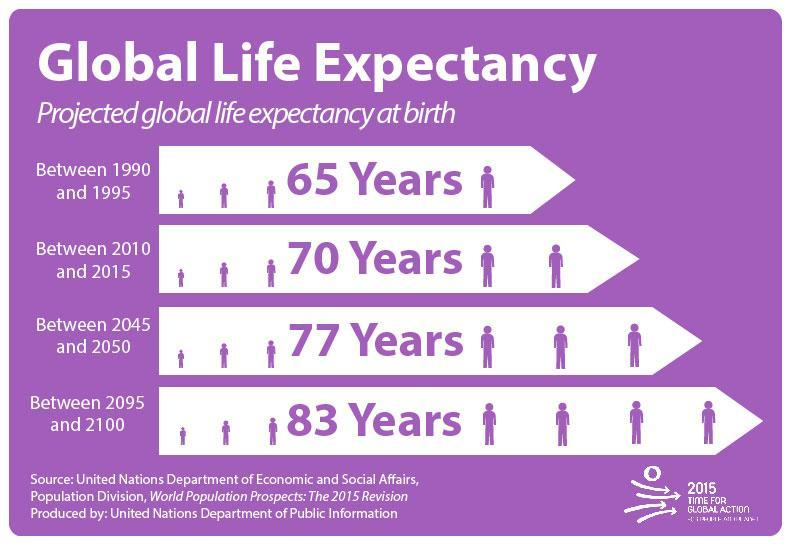How many ages mentioned in this infographic?
Answer the question with a short phrase. 4 